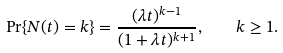<formula> <loc_0><loc_0><loc_500><loc_500>\Pr \{ N ( t ) = k \} = \frac { ( \lambda t ) ^ { k - 1 } } { ( 1 + \lambda t ) ^ { k + 1 } } , \quad k \geq 1 .</formula> 